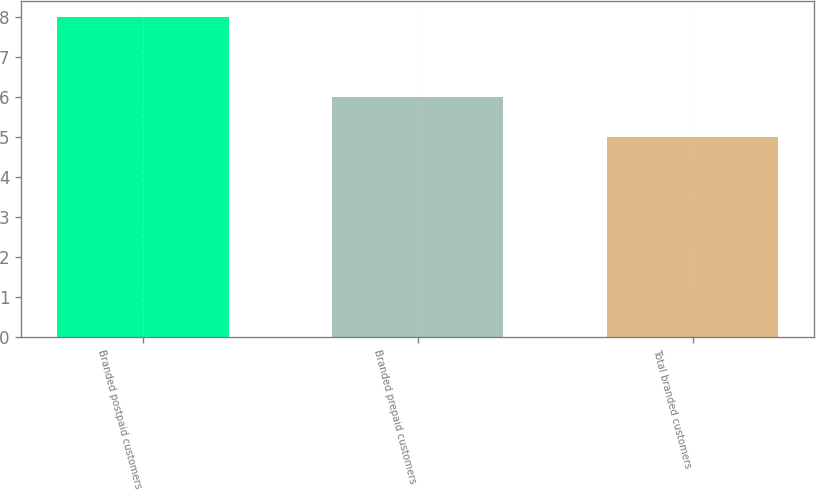Convert chart. <chart><loc_0><loc_0><loc_500><loc_500><bar_chart><fcel>Branded postpaid customers<fcel>Branded prepaid customers<fcel>Total branded customers<nl><fcel>8<fcel>6<fcel>5<nl></chart> 